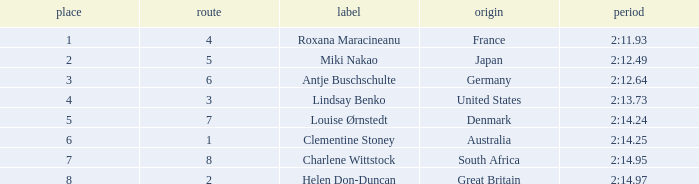What is the average Rank for a lane smaller than 3 with a nationality of Australia? 6.0. 